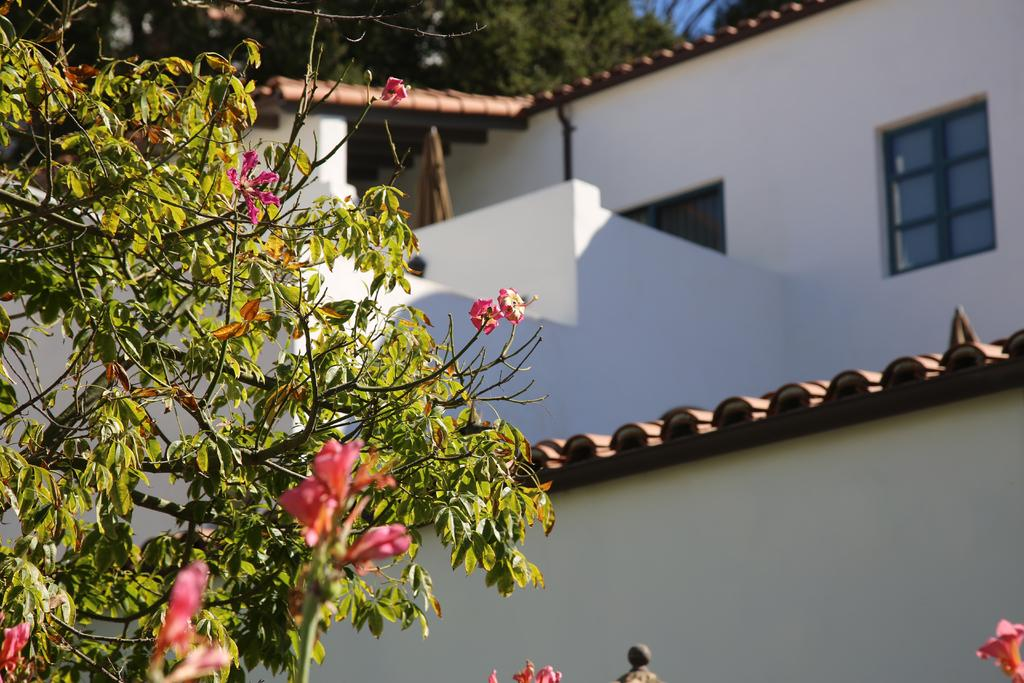What type of plant is in the image? There is a tree with flowers in the image. What is located behind the tree? There is a building behind the tree. Are there any other trees visible in the image? Yes, there are trees visible behind the tree. What can be seen in the background of the image? The sky is visible in the background of the image. What type of acoustics can be heard from the tree in the image? There is no mention of acoustics in the image, as it is a visual medium. 